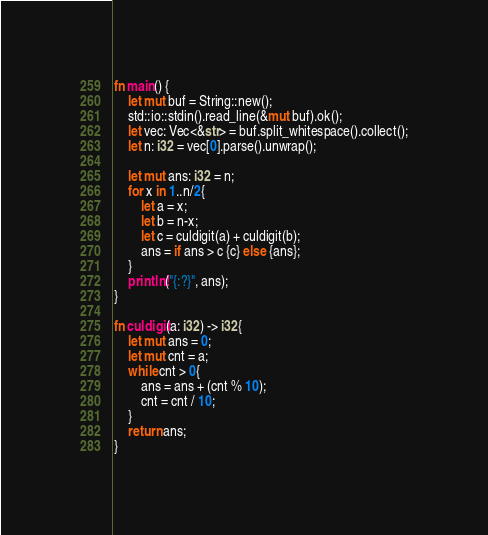Convert code to text. <code><loc_0><loc_0><loc_500><loc_500><_Rust_>fn main() {
    let mut buf = String::new();
    std::io::stdin().read_line(&mut buf).ok();
    let vec: Vec<&str> = buf.split_whitespace().collect();
    let n: i32 = vec[0].parse().unwrap();

    let mut ans: i32 = n;
    for x in 1..n/2{
        let a = x;
        let b = n-x;
        let c = culdigit(a) + culdigit(b);
        ans = if ans > c {c} else {ans};
    }
    println!("{:?}", ans);
}

fn culdigit(a: i32) -> i32{
    let mut ans = 0;
    let mut cnt = a;
    while cnt > 0{
        ans = ans + (cnt % 10);
        cnt = cnt / 10;
    }
    return ans;
}
</code> 